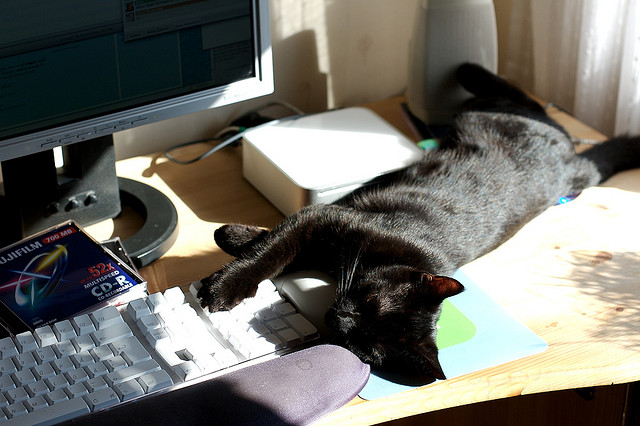Read and extract the text from this image. UJIFILM 200 MB 52 CD R MULTISPEED x 